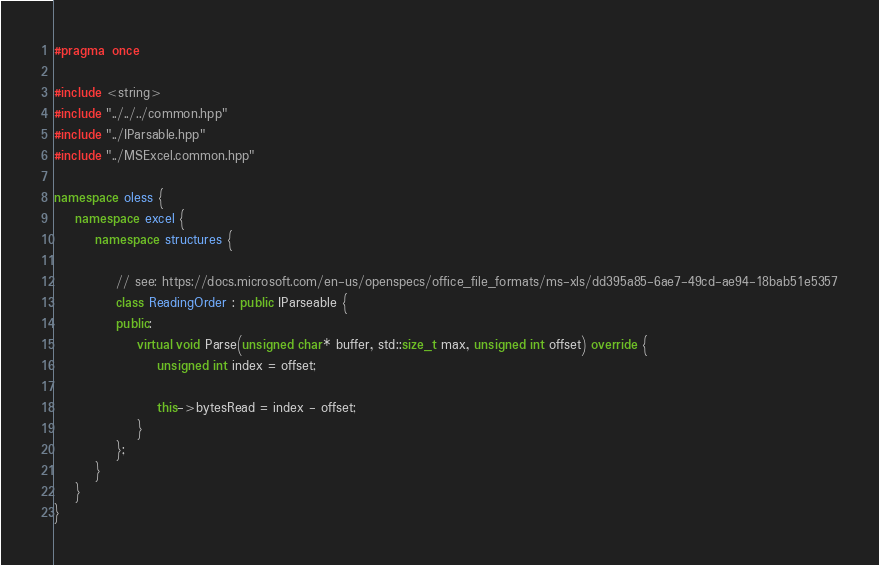<code> <loc_0><loc_0><loc_500><loc_500><_C++_>#pragma once

#include <string>
#include "../../../common.hpp"
#include "../IParsable.hpp"
#include "../MSExcel.common.hpp"

namespace oless {
	namespace excel {
		namespace structures {

            // see: https://docs.microsoft.com/en-us/openspecs/office_file_formats/ms-xls/dd395a85-6ae7-49cd-ae94-18bab51e5357
			class ReadingOrder : public IParseable {
			public:
				virtual void Parse(unsigned char* buffer, std::size_t max, unsigned int offset) override {
					unsigned int index = offset;

                    this->bytesRead = index - offset;
                }
            };
        }
    }
}
</code> 